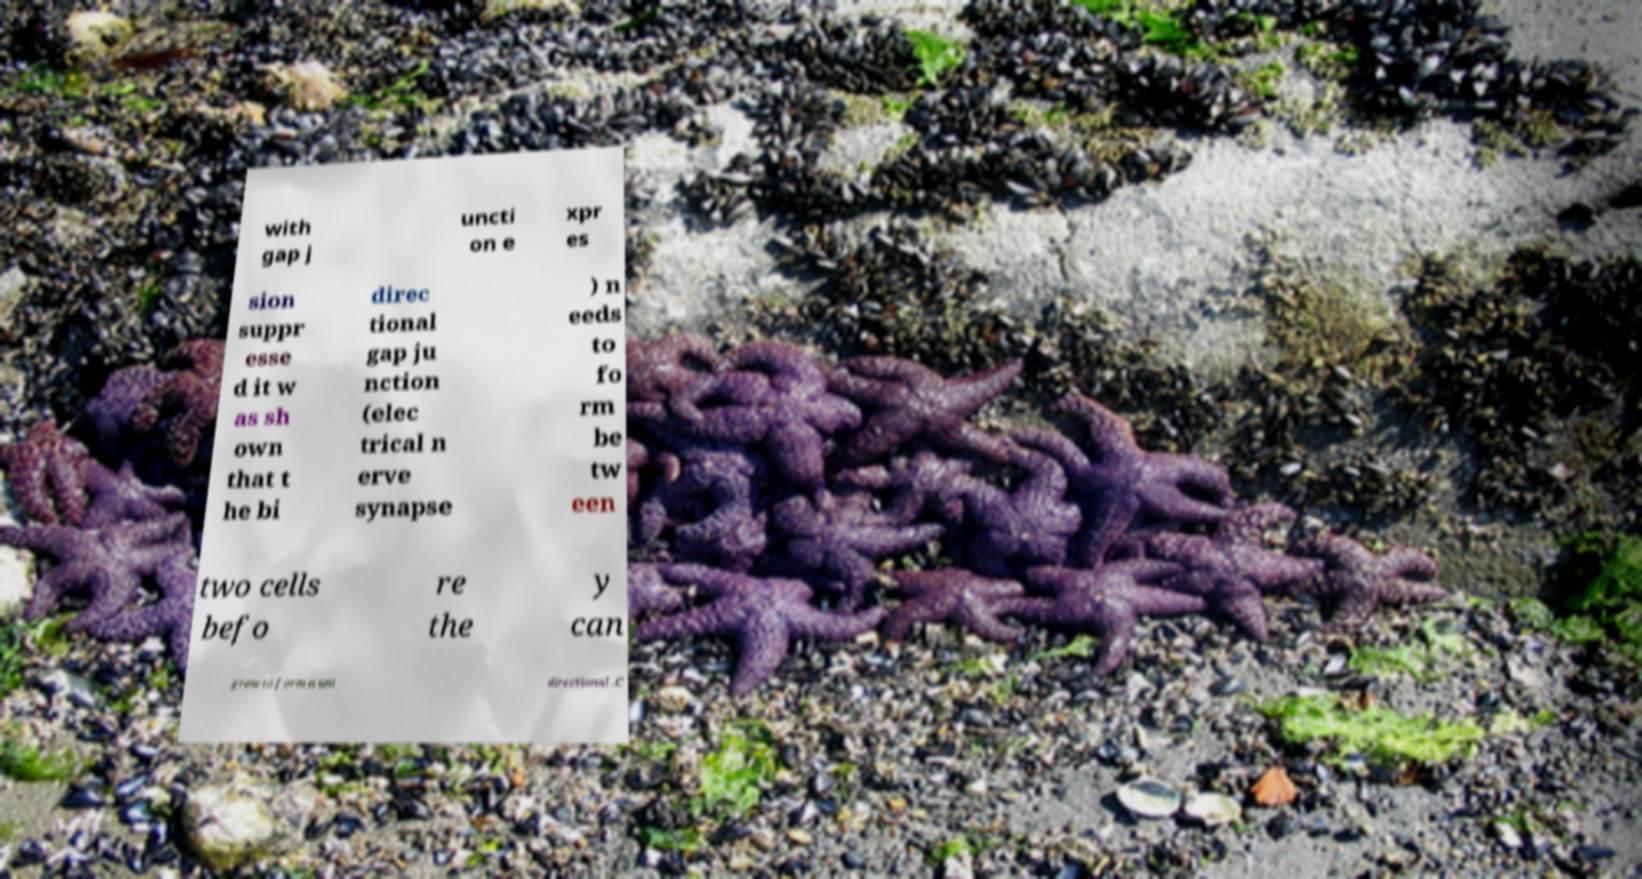I need the written content from this picture converted into text. Can you do that? with gap j uncti on e xpr es sion suppr esse d it w as sh own that t he bi direc tional gap ju nction (elec trical n erve synapse ) n eeds to fo rm be tw een two cells befo re the y can grow to form a uni directional .C 